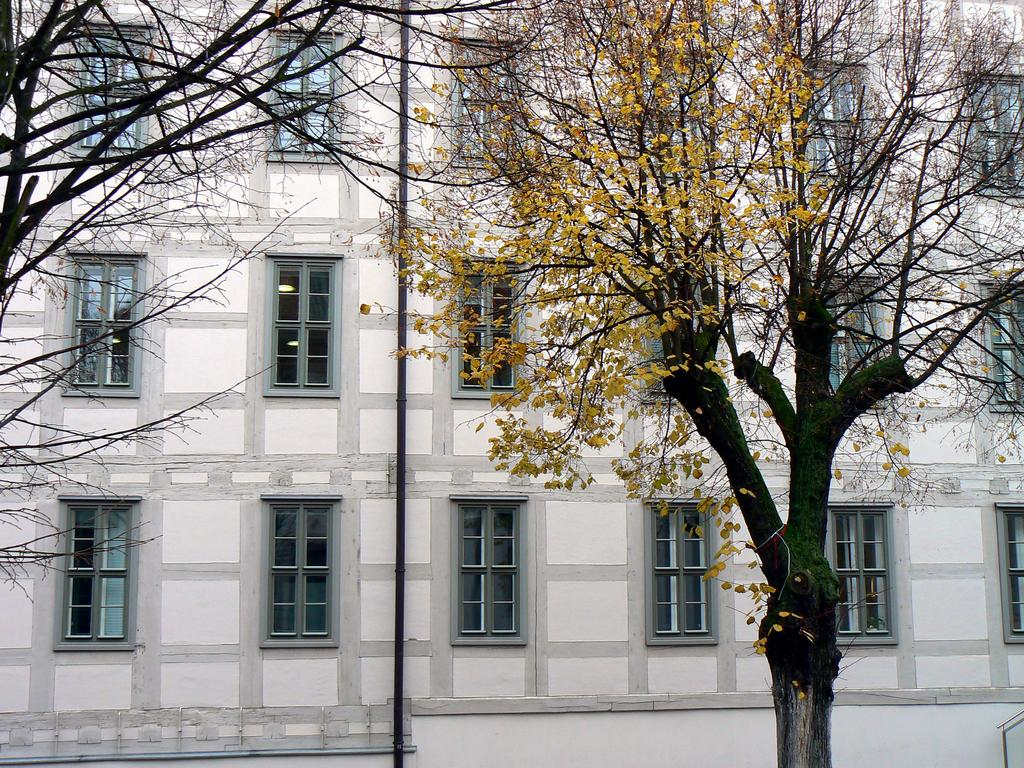What type of structure is present in the image? There is a building in the image. What can be seen in front of the building? Trees are visible in front of the building. What is the black object in the center of the image? There is a black pole in the center of the image. Where is the pole positioned? The pole is placed on a wall. How close is the pole to the windows? The pole is near to the windows. What type of boat can be seen sailing near the building in the image? There is no boat present in the image; it only features a building, trees, and a black pole. 